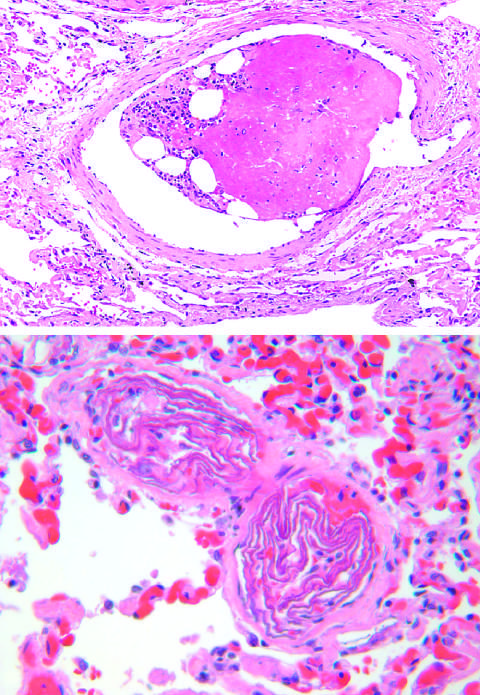what is edematous and congested?
Answer the question using a single word or phrase. The surrounding lung 